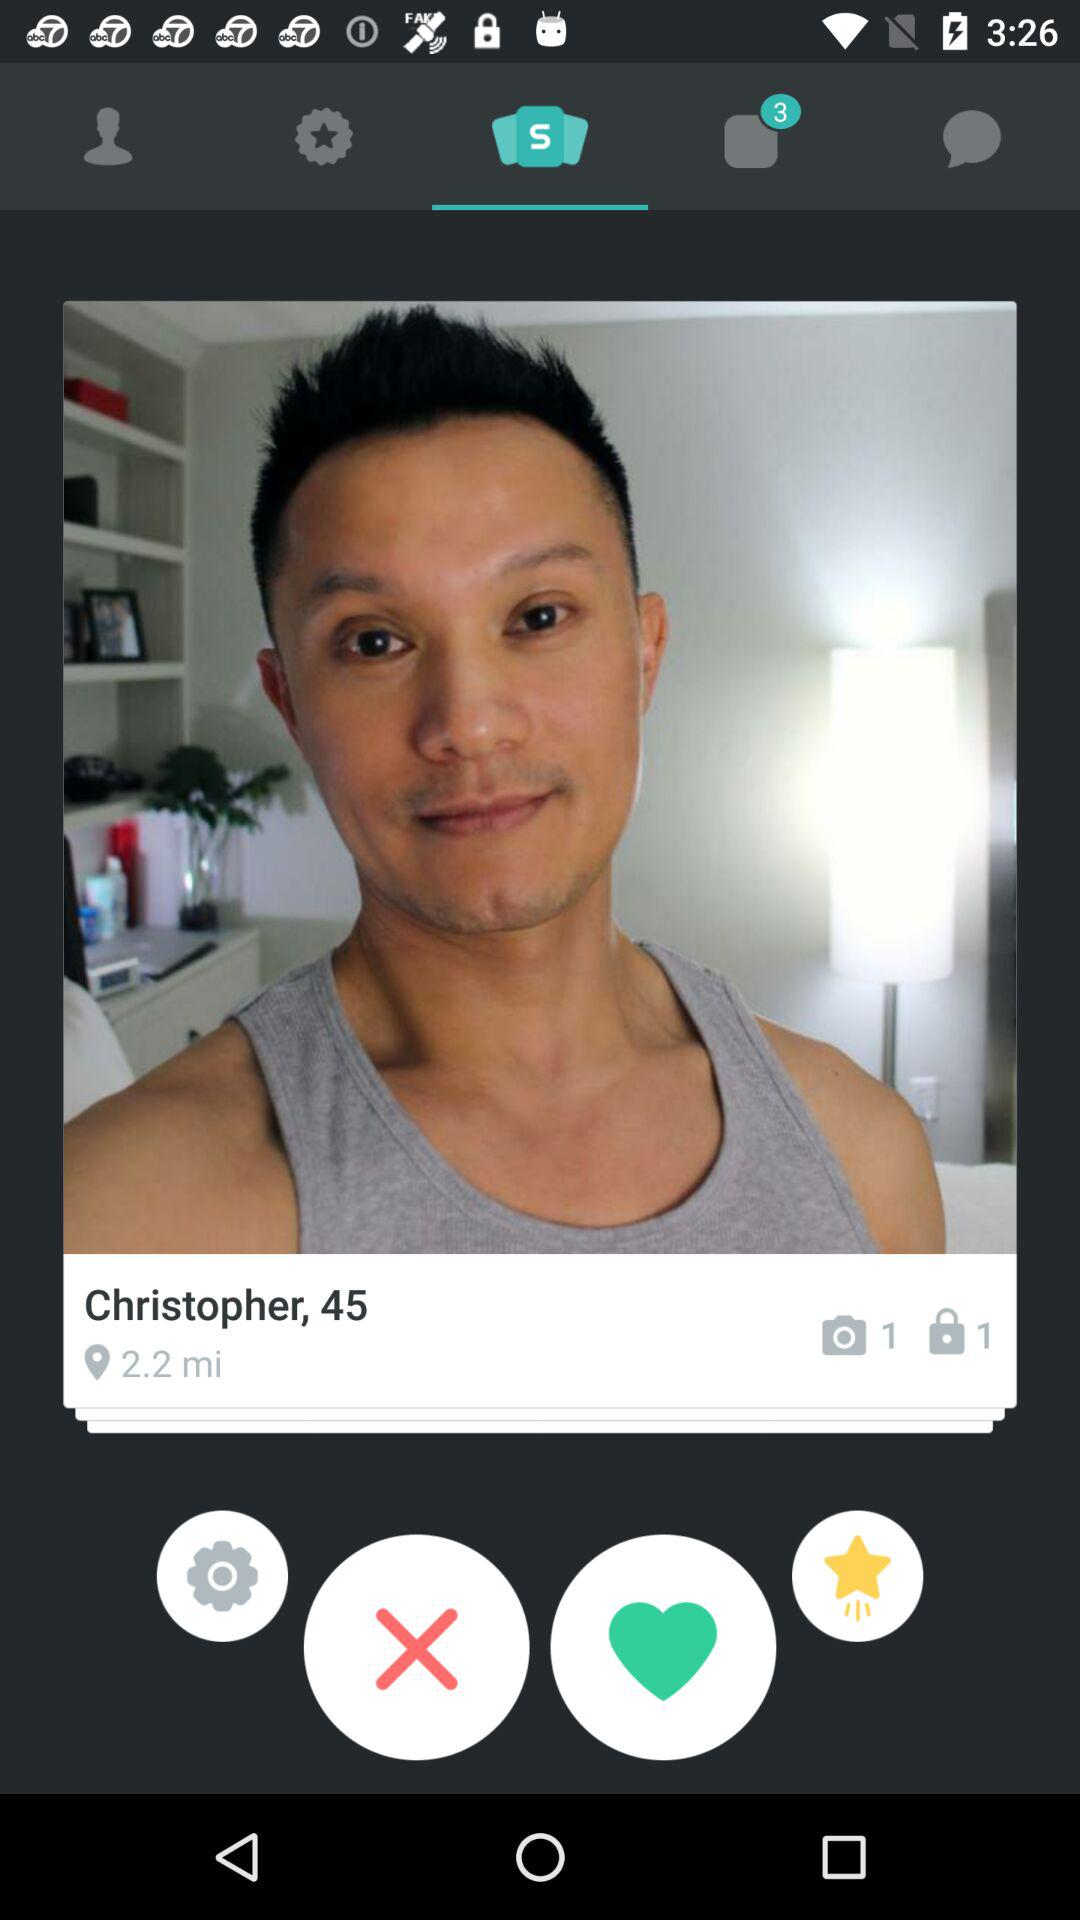What is the name of the user? The name of the user is Christopher. 